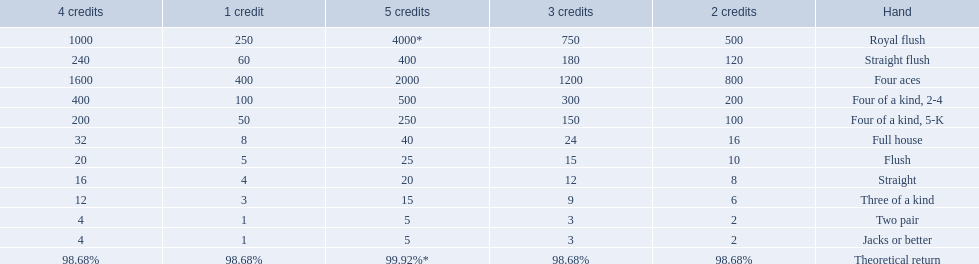Which hand is lower than straight flush? Four aces. Which hand is lower than four aces? Four of a kind, 2-4. Which hand is higher out of straight and flush? Flush. 